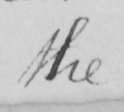What is written in this line of handwriting? the 